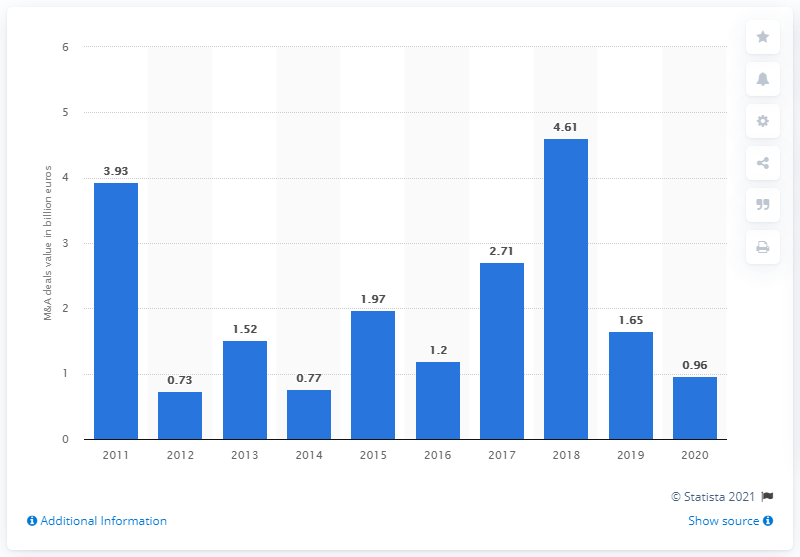Outline some significant characteristics in this image. In 2020, the value of Hungarian deals was 0.96. 